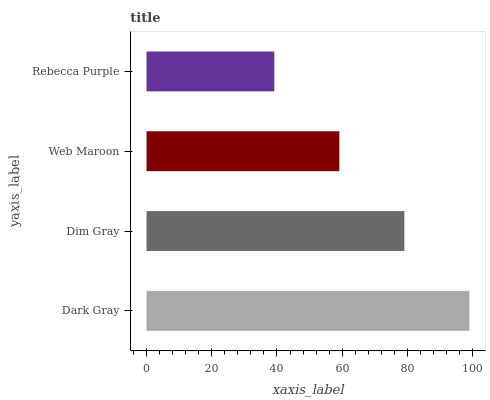Is Rebecca Purple the minimum?
Answer yes or no. Yes. Is Dark Gray the maximum?
Answer yes or no. Yes. Is Dim Gray the minimum?
Answer yes or no. No. Is Dim Gray the maximum?
Answer yes or no. No. Is Dark Gray greater than Dim Gray?
Answer yes or no. Yes. Is Dim Gray less than Dark Gray?
Answer yes or no. Yes. Is Dim Gray greater than Dark Gray?
Answer yes or no. No. Is Dark Gray less than Dim Gray?
Answer yes or no. No. Is Dim Gray the high median?
Answer yes or no. Yes. Is Web Maroon the low median?
Answer yes or no. Yes. Is Web Maroon the high median?
Answer yes or no. No. Is Dim Gray the low median?
Answer yes or no. No. 